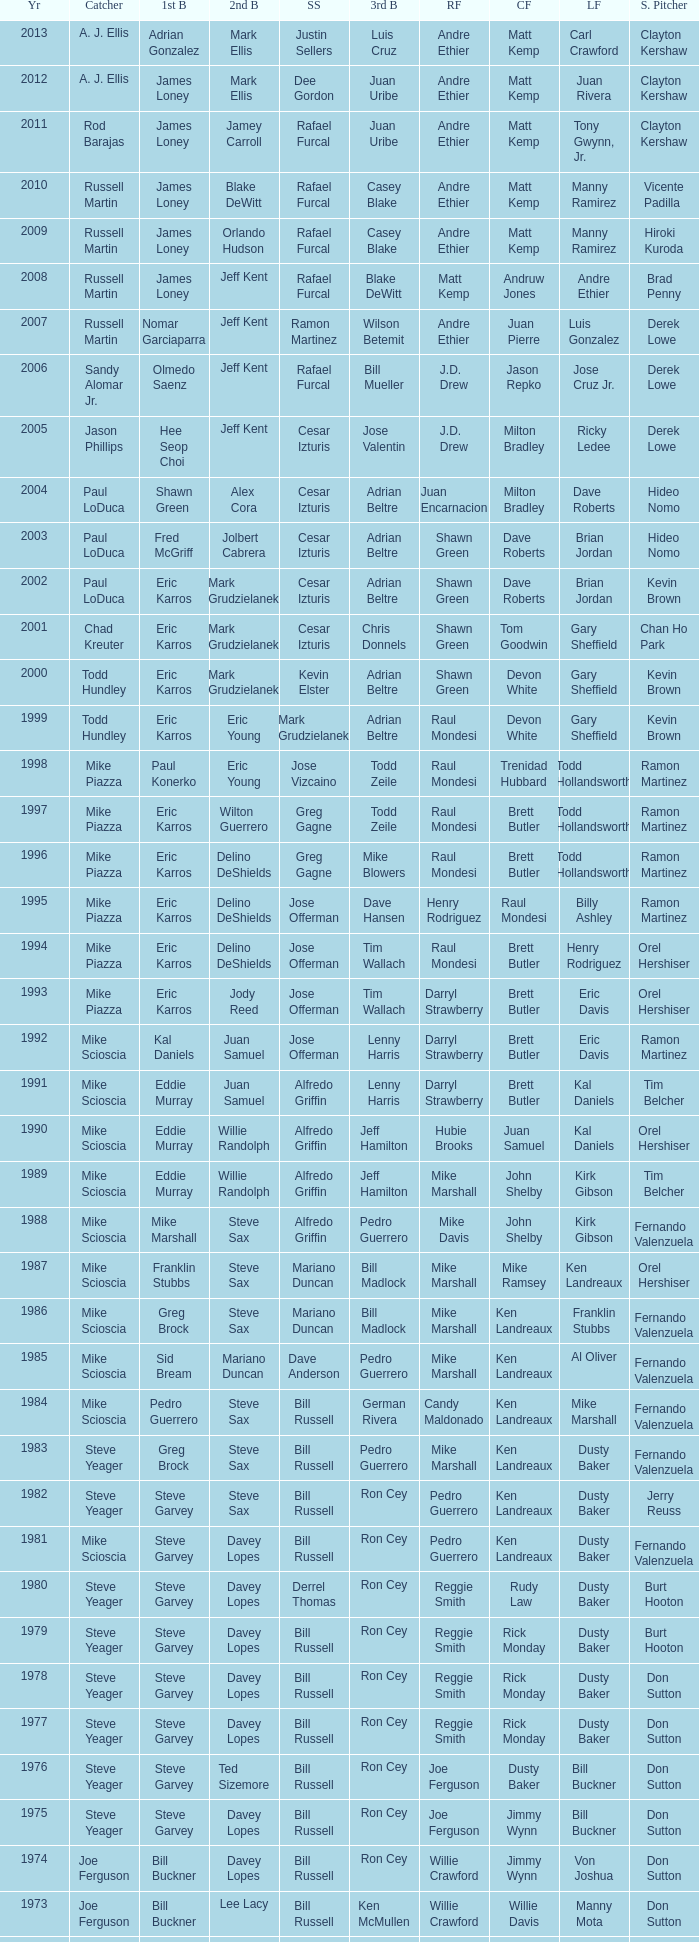Who played SS when paul konerko played 1st base? Jose Vizcaino. 